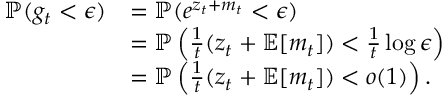Convert formula to latex. <formula><loc_0><loc_0><loc_500><loc_500>\begin{array} { r l } { \mathbb { P } ( g _ { t } < \epsilon ) } & { = \mathbb { P } ( e ^ { z _ { t } + m _ { t } } < \epsilon ) } \\ & { = \mathbb { P } \left ( \frac { 1 } { t } ( z _ { t } + \mathbb { E } [ m _ { t } ] ) < \frac { 1 } { t } \log \epsilon \right ) } \\ & { = \mathbb { P } \left ( \frac { 1 } { t } ( z _ { t } + \mathbb { E } [ m _ { t } ] ) < o ( 1 ) \right ) . } \end{array}</formula> 